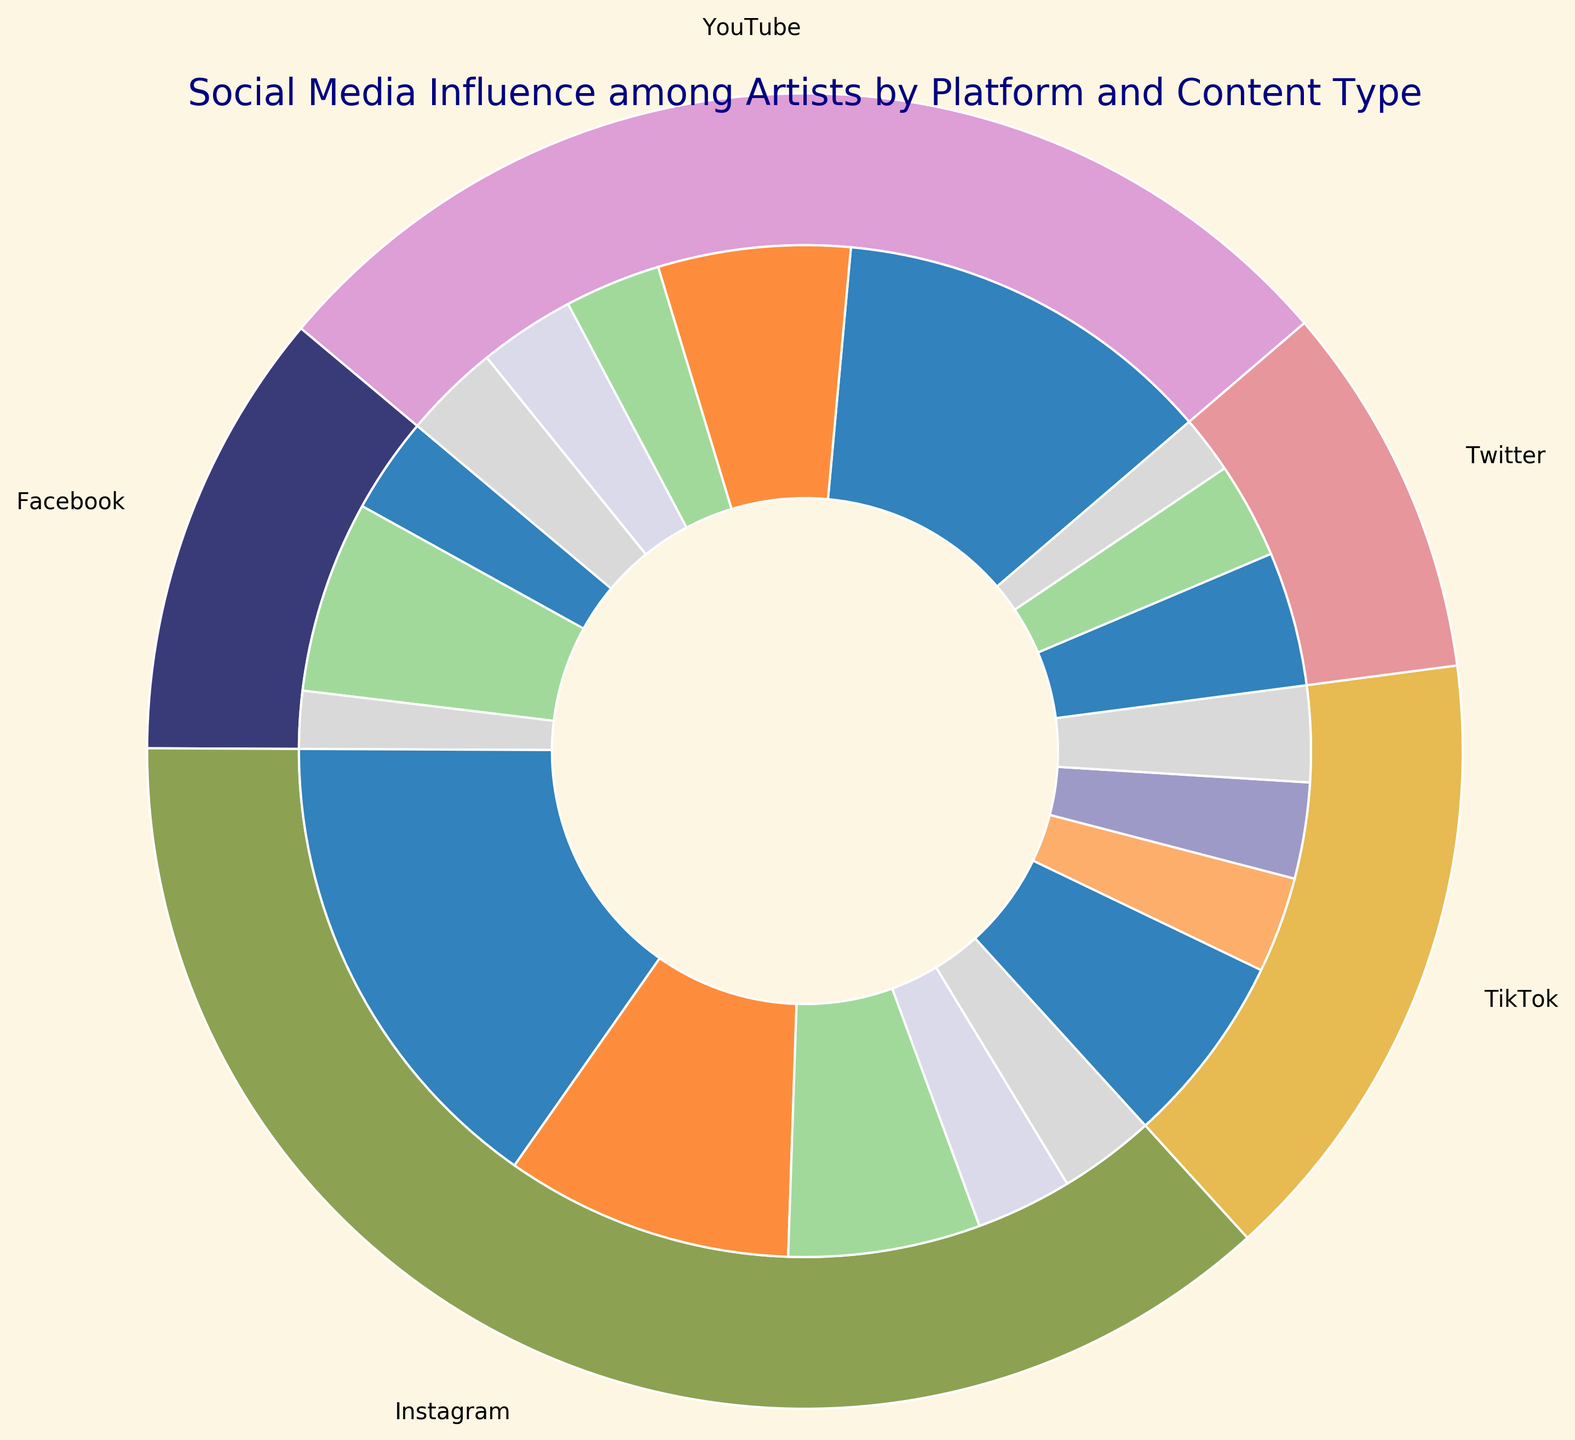What's the largest content type shared on Instagram? By observing the inner ring segment corresponding to Instagram, the largest segment appears to be for Artwork Posts.
Answer: Artwork Posts Which platform shows the highest overall percentage of content shared among artists? The outer ring, depicting platform usage, shows a large proportion for Instagram when compared visually with YouTube, TikTok, Facebook, and Twitter.
Answer: Instagram If you add up all Tutorial percentages across all platforms, what is the total? Summing up the Tutorial segments from Instagram (15%), YouTube (20%), and TikTok (5%) gives: 15% + 20% + 5% = 40%
Answer: 40% Which has a higher percentage on Facebook, Promotional Content or Personal Updates? Comparing the two segments on the inner ring for Facebook, the Promotional Content segment is visually larger than the Personal Updates segment.
Answer: Promotional Content Between YouTube and Twitter, which platform has a larger percentage of Personal Updates? Comparing the inner ring segments for Personal Updates, YouTube has a 5% segment while Twitter has a 3% segment.
Answer: YouTube What is the combined percentage of Artwork Posts and Behind-the-Scenes content across all platforms? Summing up the percentages for Artwork Posts and Behind-the-Scenes: Instagram (25% + 10%), YouTube (5% + 10%), TikTok (10% + 5%), Facebook (5% + 0%), Twitter (7% + 0%) = 25% + 10% + 5% + 10% + 10% + 5% + 5% + 7% = 77%
Answer: 77% Which content type has the smallest percentage on Instagram? Observing the inner ring segments for Instagram, Promotional Content and Personal Updates both appear as the smallest, each with 5%.
Answer: Promotional Content and Personal Updates (tie) Do artists share more Tutorial content on Instagram or TikTok? Comparing the inner ring segments, Instagram's Tutorial content shows 15% while TikTok's Tutorial content shows only 5%.
Answer: Instagram How many more percent of Tutorials are shared on YouTube compared to Instagram? The Tutorial content on YouTube is 20%, while on Instagram it is 15%. The difference is 20% - 15% = 5%.
Answer: 5% What's the most frequent type of content shared on Twitter? The inner ring for Twitter shows Artwork Posts with the largest segment of 7%.
Answer: Artwork Posts 